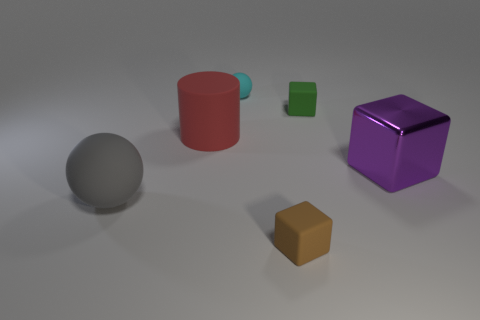Add 1 tiny blocks. How many objects exist? 7 Subtract all balls. How many objects are left? 4 Add 6 metallic blocks. How many metallic blocks are left? 7 Add 5 big yellow metal balls. How many big yellow metal balls exist? 5 Subtract 0 cyan blocks. How many objects are left? 6 Subtract all large purple objects. Subtract all red matte cylinders. How many objects are left? 4 